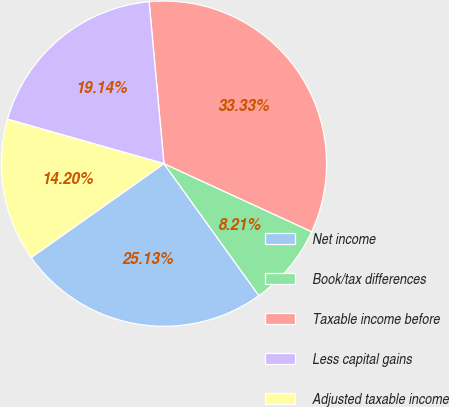Convert chart to OTSL. <chart><loc_0><loc_0><loc_500><loc_500><pie_chart><fcel>Net income<fcel>Book/tax differences<fcel>Taxable income before<fcel>Less capital gains<fcel>Adjusted taxable income<nl><fcel>25.13%<fcel>8.21%<fcel>33.33%<fcel>19.14%<fcel>14.2%<nl></chart> 